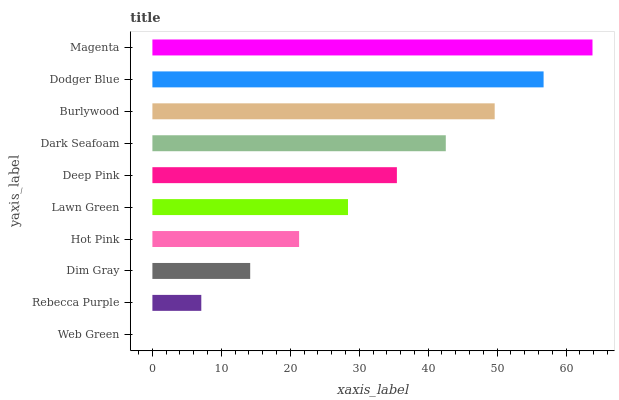Is Web Green the minimum?
Answer yes or no. Yes. Is Magenta the maximum?
Answer yes or no. Yes. Is Rebecca Purple the minimum?
Answer yes or no. No. Is Rebecca Purple the maximum?
Answer yes or no. No. Is Rebecca Purple greater than Web Green?
Answer yes or no. Yes. Is Web Green less than Rebecca Purple?
Answer yes or no. Yes. Is Web Green greater than Rebecca Purple?
Answer yes or no. No. Is Rebecca Purple less than Web Green?
Answer yes or no. No. Is Deep Pink the high median?
Answer yes or no. Yes. Is Lawn Green the low median?
Answer yes or no. Yes. Is Dark Seafoam the high median?
Answer yes or no. No. Is Dodger Blue the low median?
Answer yes or no. No. 